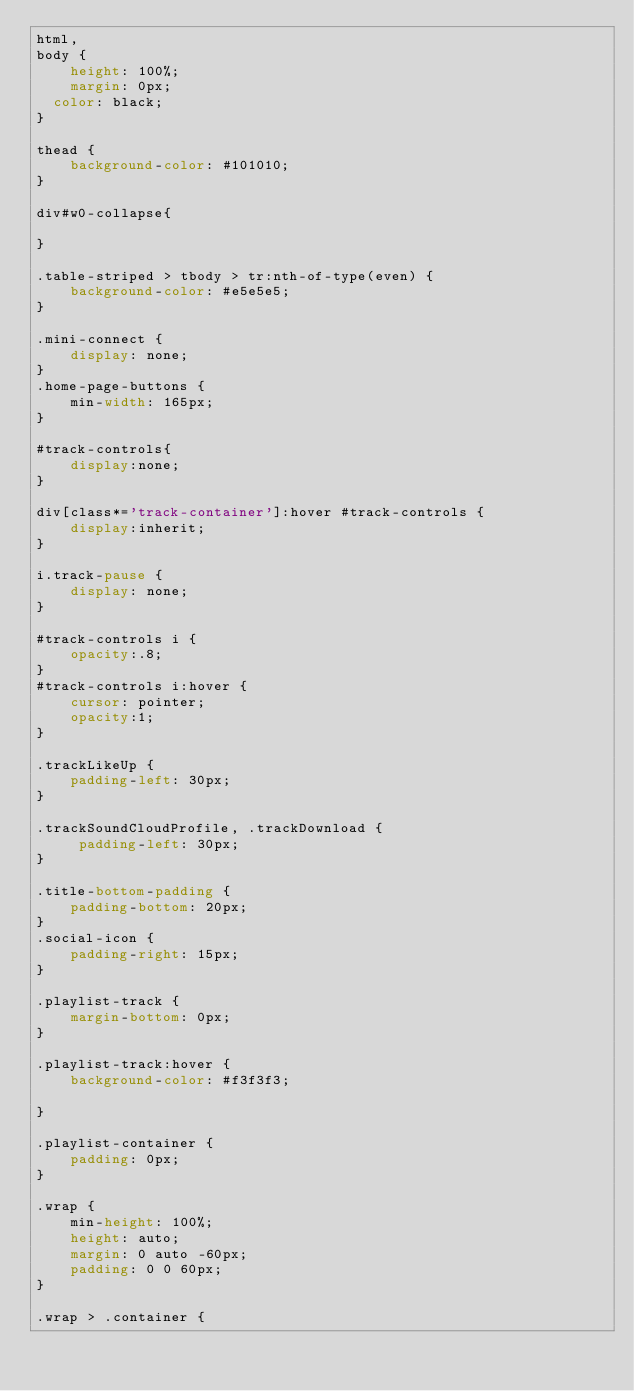Convert code to text. <code><loc_0><loc_0><loc_500><loc_500><_CSS_>html,
body {
    height: 100%;
    margin: 0px;
  color: black;
}

thead {
    background-color: #101010;
}

div#w0-collapse{

}

.table-striped > tbody > tr:nth-of-type(even) {
    background-color: #e5e5e5;
}

.mini-connect {
    display: none;
}
.home-page-buttons {
    min-width: 165px;
}

#track-controls{
    display:none;
}

div[class*='track-container']:hover #track-controls {
    display:inherit;
}

i.track-pause {
    display: none;
}

#track-controls i {
    opacity:.8;
}
#track-controls i:hover {
    cursor: pointer;
    opacity:1;
}

.trackLikeUp {
    padding-left: 30px;
}

.trackSoundCloudProfile, .trackDownload {
     padding-left: 30px;
}

.title-bottom-padding {
    padding-bottom: 20px;
}
.social-icon {
    padding-right: 15px;
}

.playlist-track {
    margin-bottom: 0px;
}

.playlist-track:hover {
    background-color: #f3f3f3;

}

.playlist-container {
    padding: 0px;
}

.wrap {
    min-height: 100%;
    height: auto;
    margin: 0 auto -60px;
    padding: 0 0 60px;
}

.wrap > .container {</code> 